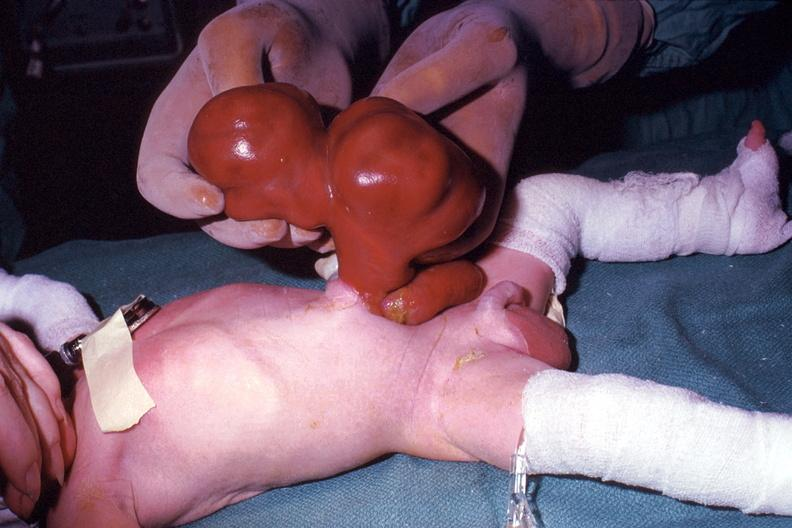what is a photo taken?
Answer the question using a single word or phrase. During life large lesion 